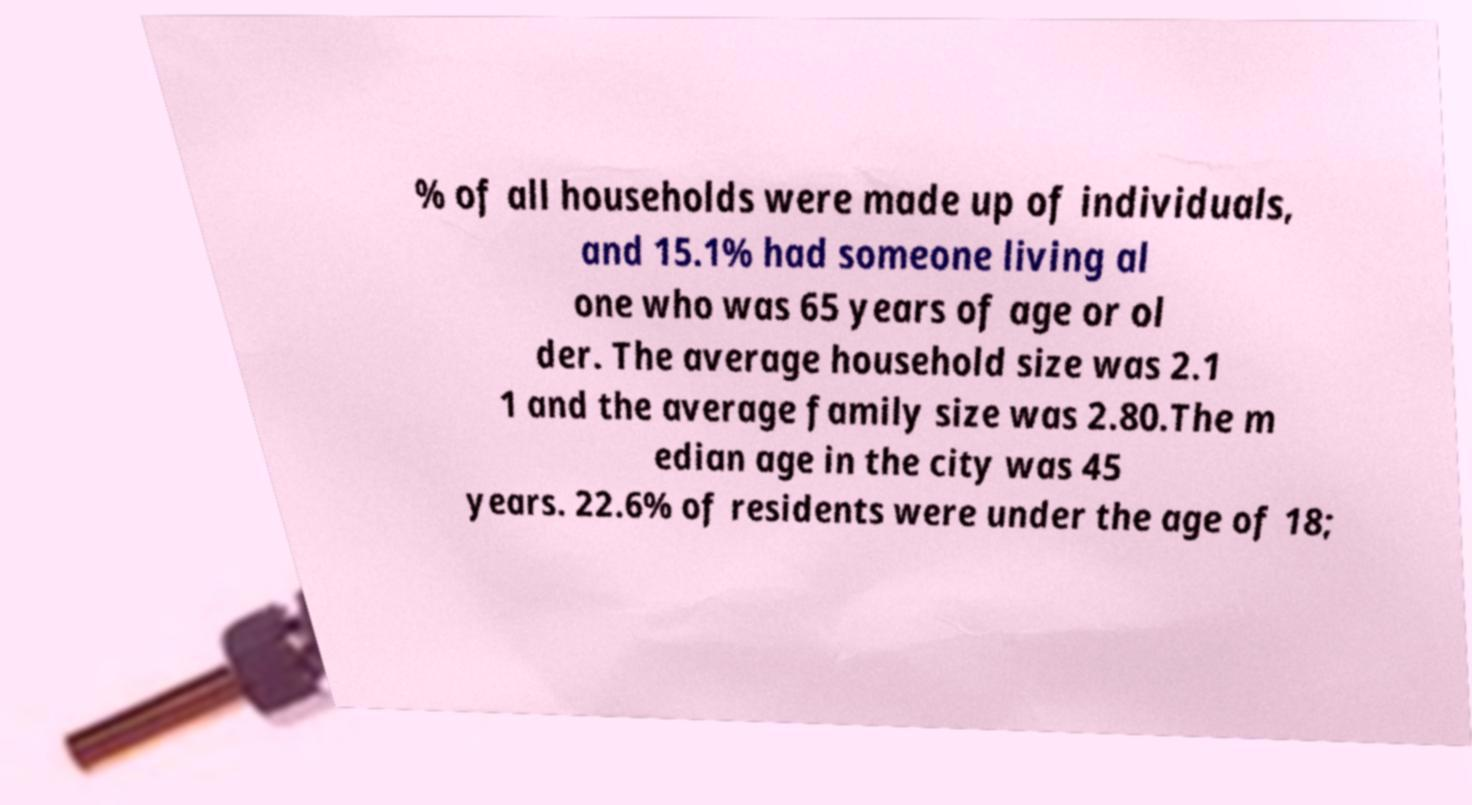Please read and relay the text visible in this image. What does it say? % of all households were made up of individuals, and 15.1% had someone living al one who was 65 years of age or ol der. The average household size was 2.1 1 and the average family size was 2.80.The m edian age in the city was 45 years. 22.6% of residents were under the age of 18; 